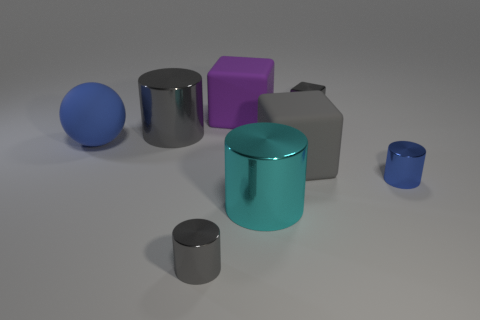What size is the other block that is the same color as the metal block?
Offer a terse response. Large. What number of metal things are the same color as the small metal block?
Your answer should be very brief. 2. What is the size of the blue cylinder that is made of the same material as the big cyan cylinder?
Give a very brief answer. Small. There is a blue thing in front of the large blue ball; what shape is it?
Make the answer very short. Cylinder. There is a gray shiny object that is the same shape as the big purple thing; what is its size?
Offer a very short reply. Small. There is a tiny gray metal object that is behind the rubber cube on the left side of the big gray matte cube; what number of small shiny things are on the left side of it?
Your answer should be very brief. 1. Is the number of objects that are right of the large purple rubber object the same as the number of gray things?
Keep it short and to the point. Yes. How many cylinders are tiny blue objects or matte objects?
Offer a very short reply. 1. Is the number of blue shiny objects that are on the left side of the gray rubber cube the same as the number of small gray objects that are behind the blue metallic cylinder?
Provide a short and direct response. No. What color is the small shiny cube?
Make the answer very short. Gray. 